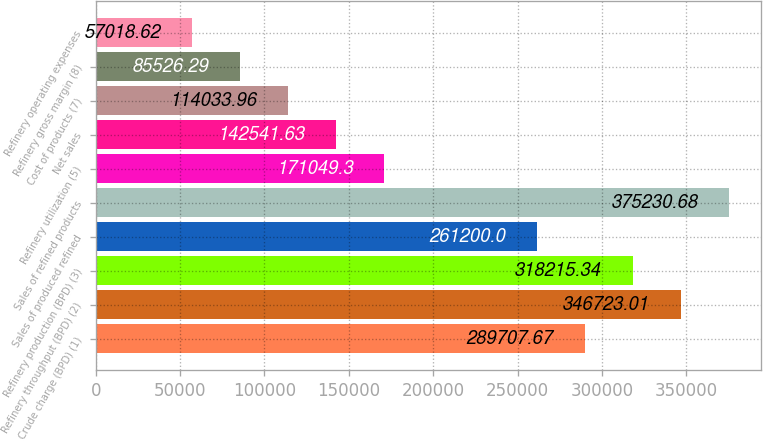Convert chart to OTSL. <chart><loc_0><loc_0><loc_500><loc_500><bar_chart><fcel>Crude charge (BPD) (1)<fcel>Refinery throughput (BPD) (2)<fcel>Refinery production (BPD) (3)<fcel>Sales of produced refined<fcel>Sales of refined products<fcel>Refinery utilization (5)<fcel>Net sales<fcel>Cost of products (7)<fcel>Refinery gross margin (8)<fcel>Refinery operating expenses<nl><fcel>289708<fcel>346723<fcel>318215<fcel>261200<fcel>375231<fcel>171049<fcel>142542<fcel>114034<fcel>85526.3<fcel>57018.6<nl></chart> 